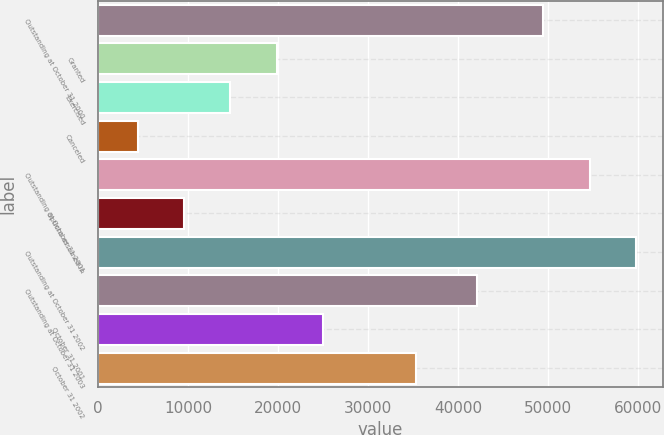<chart> <loc_0><loc_0><loc_500><loc_500><bar_chart><fcel>Outstanding at October 31 2000<fcel>Granted<fcel>Exercised<fcel>Canceled<fcel>Outstanding at October 31 2001<fcel>Options assumed in<fcel>Outstanding at October 31 2002<fcel>Outstanding at October 31 2003<fcel>October 31 2001<fcel>October 31 2002<nl><fcel>49490<fcel>19849.8<fcel>14691.2<fcel>4374<fcel>54648.6<fcel>9532.6<fcel>59807.2<fcel>42119<fcel>25008.4<fcel>35325.6<nl></chart> 